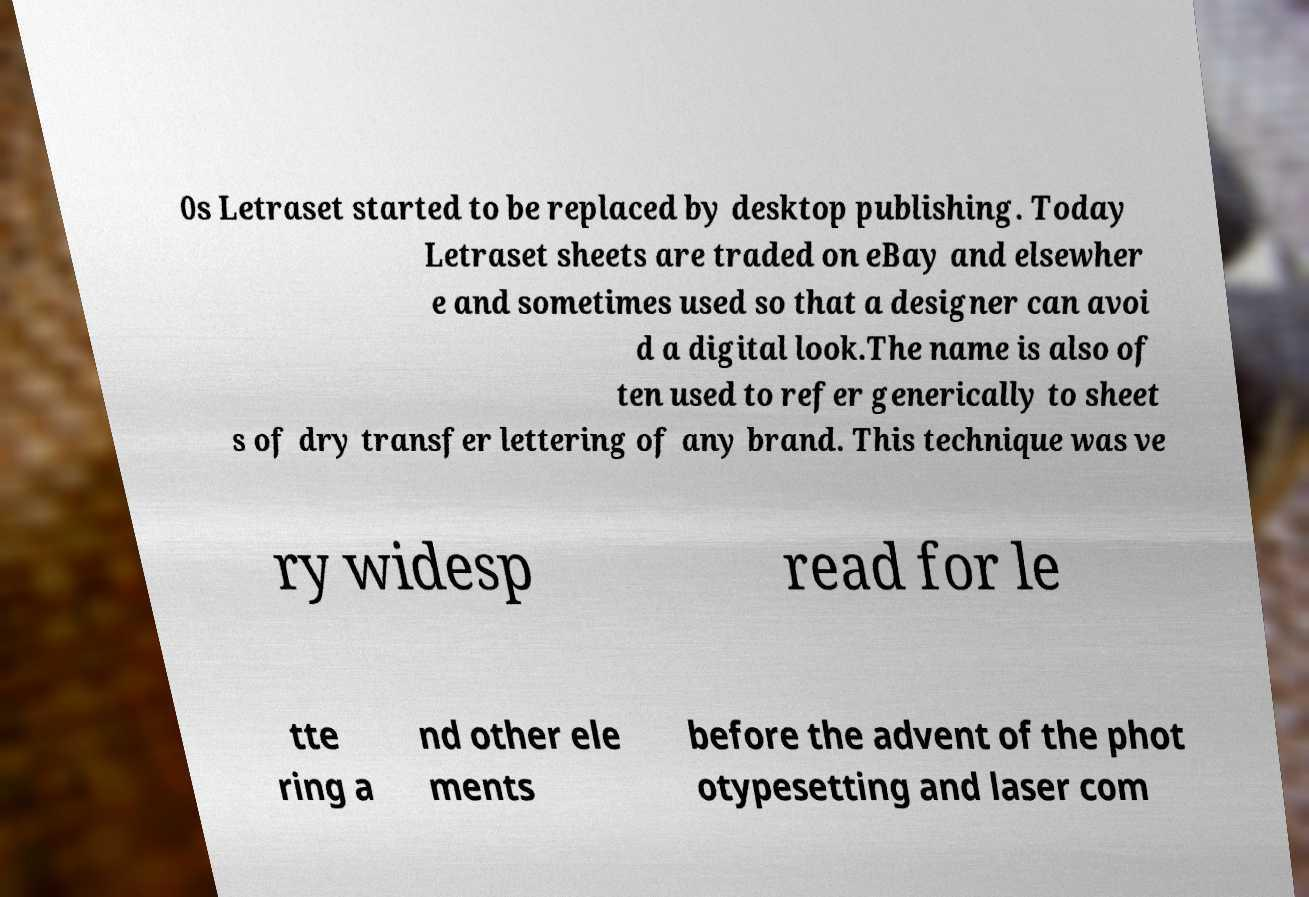There's text embedded in this image that I need extracted. Can you transcribe it verbatim? 0s Letraset started to be replaced by desktop publishing. Today Letraset sheets are traded on eBay and elsewher e and sometimes used so that a designer can avoi d a digital look.The name is also of ten used to refer generically to sheet s of dry transfer lettering of any brand. This technique was ve ry widesp read for le tte ring a nd other ele ments before the advent of the phot otypesetting and laser com 